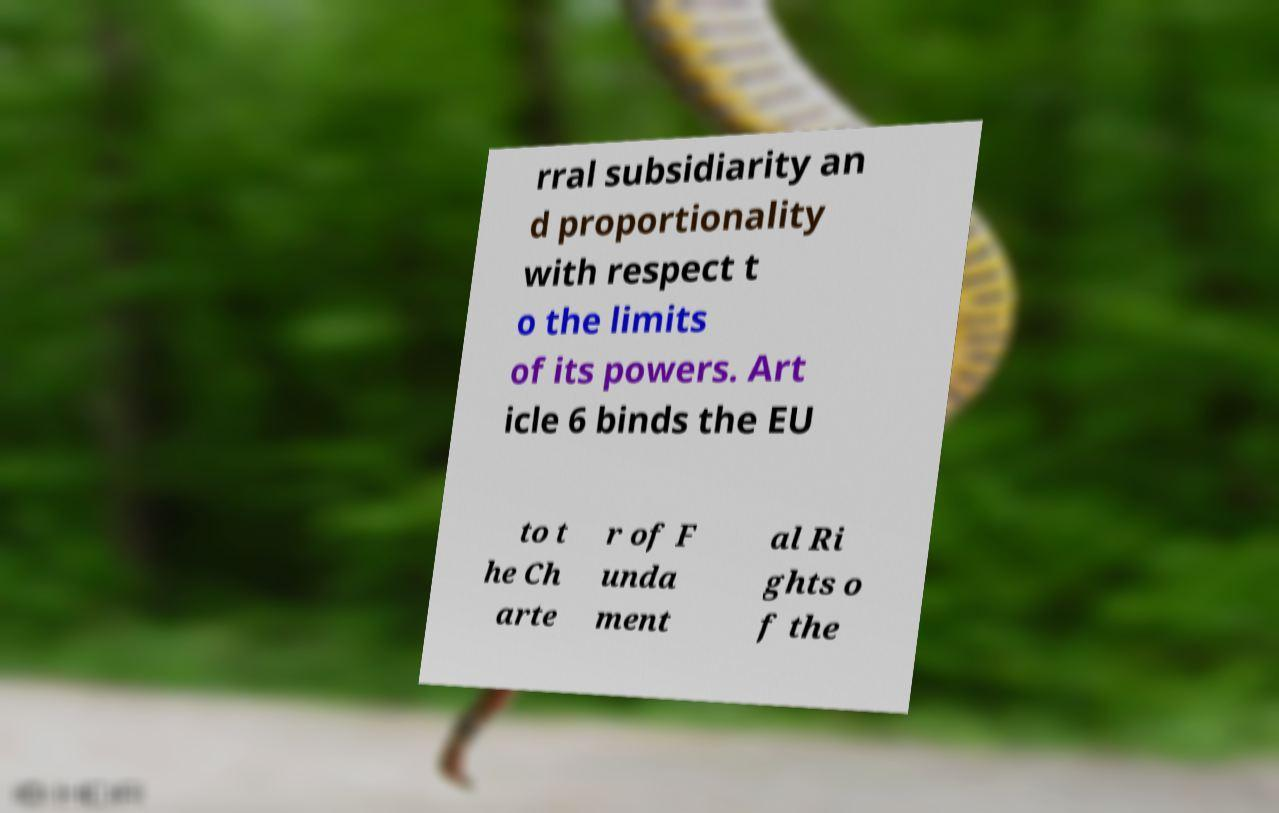Could you extract and type out the text from this image? rral subsidiarity an d proportionality with respect t o the limits of its powers. Art icle 6 binds the EU to t he Ch arte r of F unda ment al Ri ghts o f the 